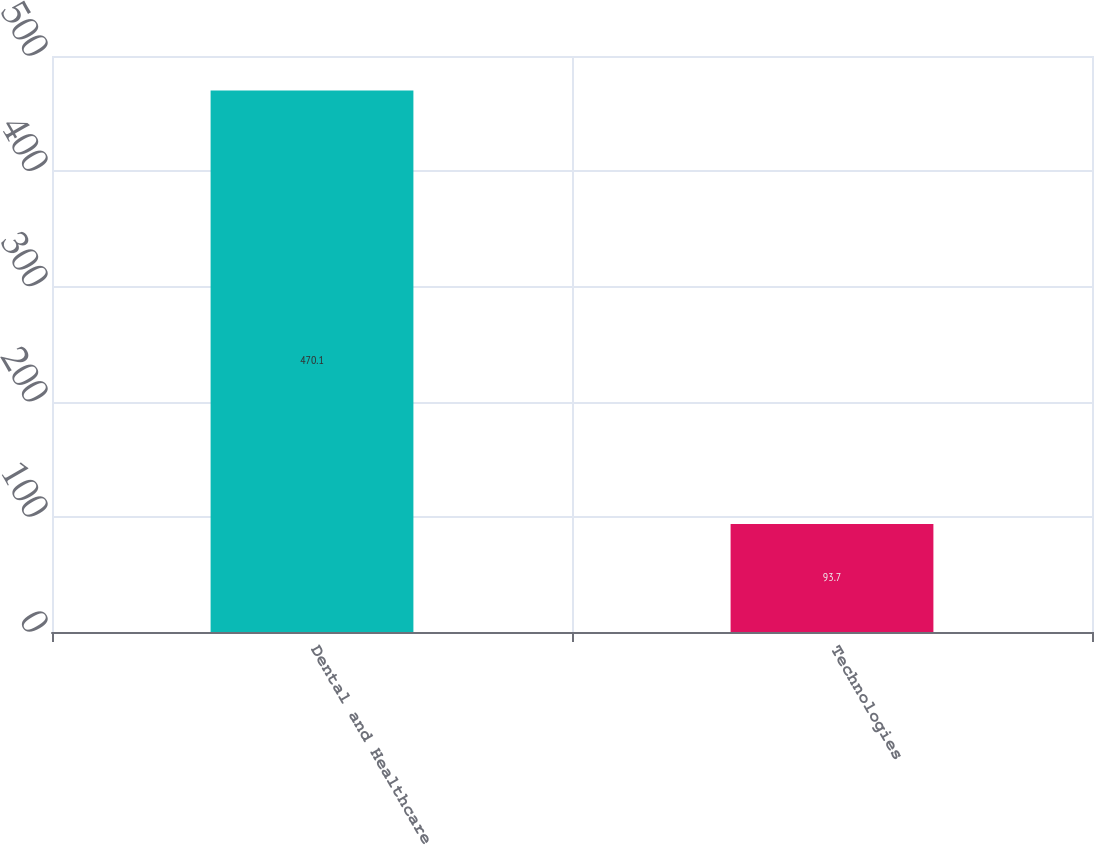<chart> <loc_0><loc_0><loc_500><loc_500><bar_chart><fcel>Dental and Healthcare<fcel>Technologies<nl><fcel>470.1<fcel>93.7<nl></chart> 